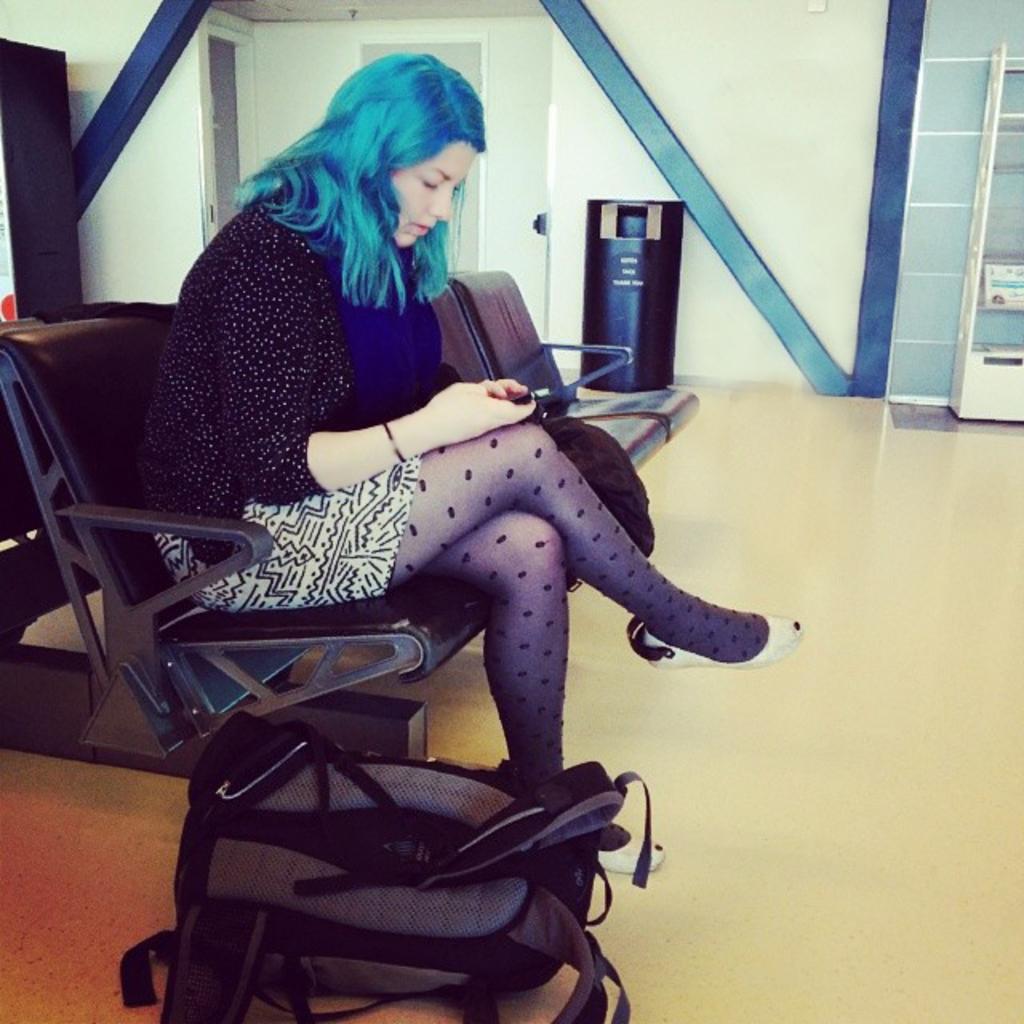Could you give a brief overview of what you see in this image? Here we can see a lady sitting on a chair with a mobile phone in her hand and beside her there is a bag present 